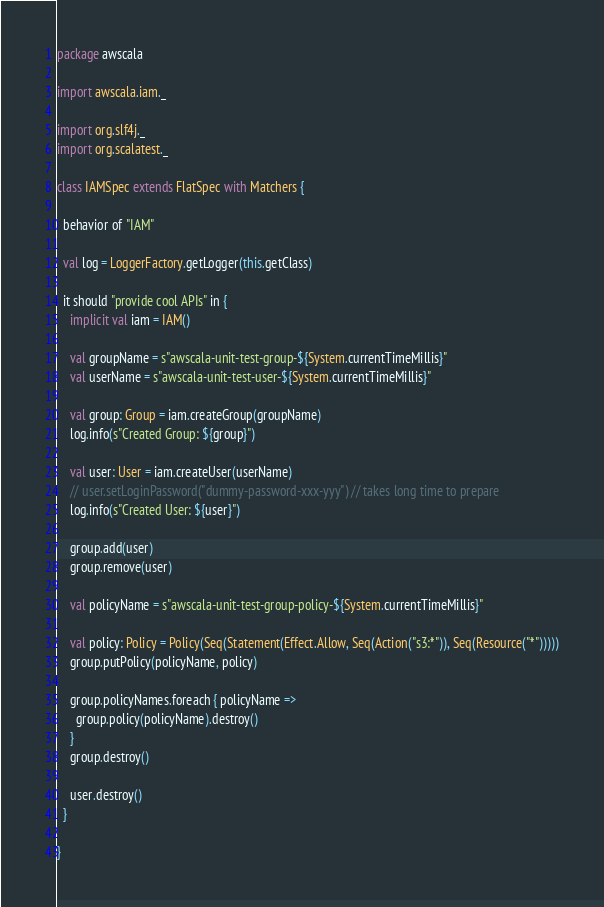Convert code to text. <code><loc_0><loc_0><loc_500><loc_500><_Scala_>package awscala

import awscala.iam._

import org.slf4j._
import org.scalatest._

class IAMSpec extends FlatSpec with Matchers {

  behavior of "IAM"

  val log = LoggerFactory.getLogger(this.getClass)

  it should "provide cool APIs" in {
    implicit val iam = IAM()

    val groupName = s"awscala-unit-test-group-${System.currentTimeMillis}"
    val userName = s"awscala-unit-test-user-${System.currentTimeMillis}"

    val group: Group = iam.createGroup(groupName)
    log.info(s"Created Group: ${group}")

    val user: User = iam.createUser(userName)
    // user.setLoginPassword("dummy-password-xxx-yyy") // takes long time to prepare
    log.info(s"Created User: ${user}")

    group.add(user)
    group.remove(user)

    val policyName = s"awscala-unit-test-group-policy-${System.currentTimeMillis}"

    val policy: Policy = Policy(Seq(Statement(Effect.Allow, Seq(Action("s3:*")), Seq(Resource("*")))))
    group.putPolicy(policyName, policy)

    group.policyNames.foreach { policyName =>
      group.policy(policyName).destroy()
    }
    group.destroy()

    user.destroy()
  }

}
</code> 